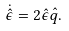<formula> <loc_0><loc_0><loc_500><loc_500>\dot { \hat { \epsilon } } = 2 \hat { \epsilon } \hat { q } .</formula> 